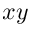<formula> <loc_0><loc_0><loc_500><loc_500>x y</formula> 